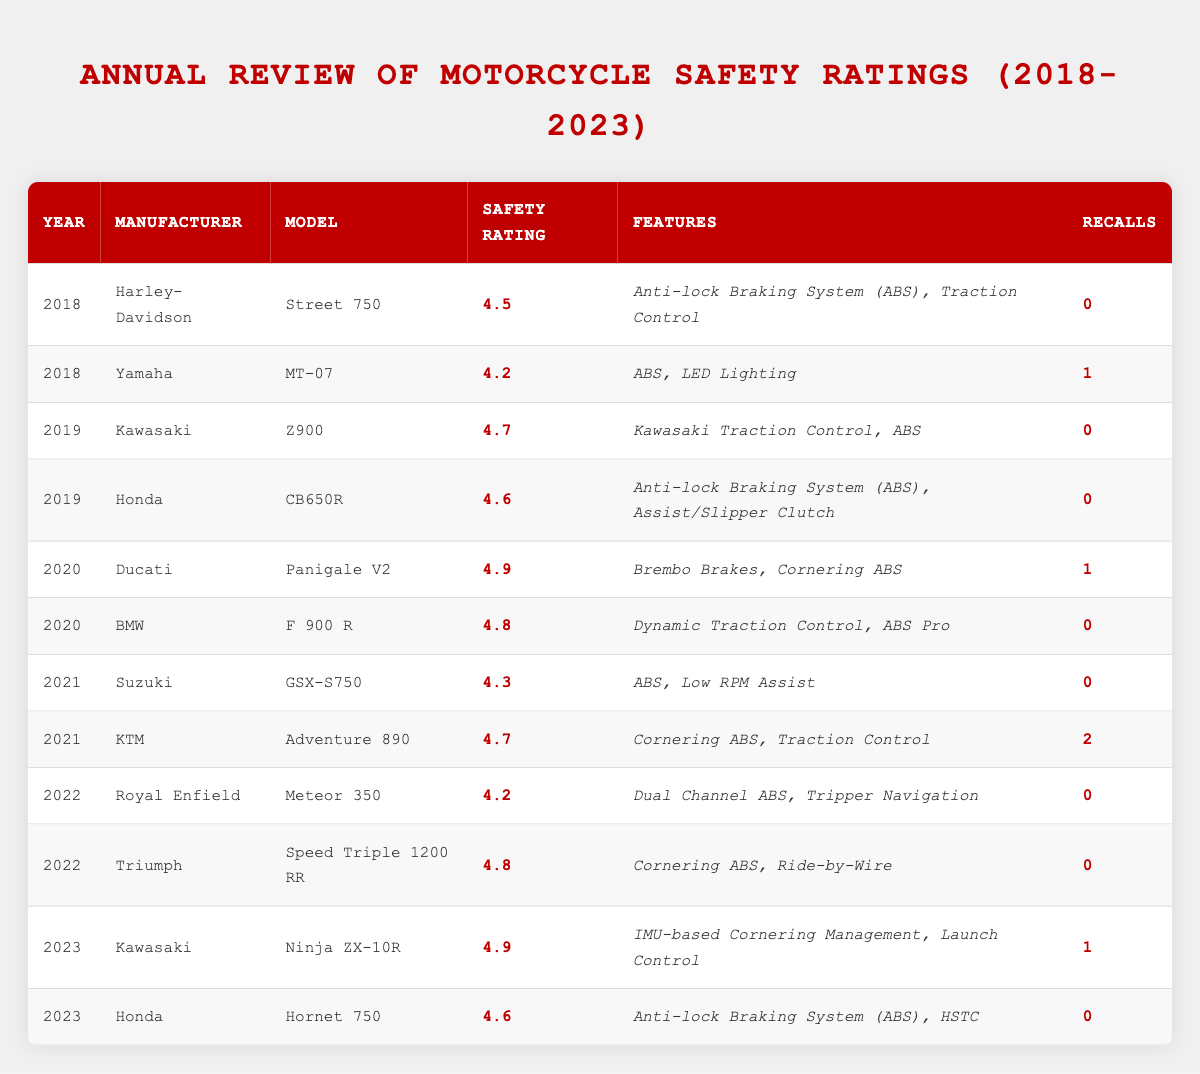What is the highest safety rating achieved in 2020? The highest safety rating in 2020 is found by comparing the ratings of Ducati Panigale V2 (4.9) and BMW F 900 R (4.8). Here, 4.9 is the highest.
Answer: 4.9 Which manufacturer had a model with the least recalls in 2019? In 2019, both Kawasaki Z900 and Honda CB650R had 0 recalls, which is the least.
Answer: Kawasaki and Honda What is the average safety rating from 2018 to 2023? The safety ratings from 2018 to 2023 are: 4.5, 4.2, 4.7, 4.6, 4.9, 4.8, 4.3, 4.7, 4.2, 4.8, 4.9, and 4.6. The total is 53.4. There are 12 models, so the average is 53.4/12 = 4.45.
Answer: 4.45 Which year had the most recalls across all models? Looking at the recalls per model, in 2021, KTM Adventure 890 had 2 recalls while all other years' recalls either had 0 or 1 (2018 - 0, 2019 - 0, 2020 - 1, 2022 - 0, 2023 - 1). Therefore, 2021 has the most recalls.
Answer: 2021 What percentage of models in 2022 had a safety rating of 4.5 or higher? In 2022, there are 2 models: Royal Enfield Meteor 350 (4.2) and Triumph Speed Triple 1200 RR (4.8). Only the Triumph model has a safety rating of 4.5 or higher. Therefore, the percentage is (1/2) * 100 = 50%.
Answer: 50% Did any motorcycle model in 2023 have a safety rating lower than 4.5? In 2023, the models are Kawasaki Ninja ZX-10R (4.9) and Honda Hornet 750 (4.6). Both ratings are above 4.5. Thus, no model had a rating lower than 4.5.
Answer: No What is the difference in safety ratings between the highest-rated model in 2020 and the highest-rated model in 2023? The highest-rated model in 2020 is Ducati Panigale V2 with 4.9, and the highest-rated model in 2023 is Kawasaki Ninja ZX-10R, also with 4.9. The difference is 4.9 - 4.9 = 0.
Answer: 0 How many manufacturers had models rated 4.7 or higher in 2019? In 2019, Kawasaki Z900 (4.7) and Honda CB650R (4.6) met the criteria. Only Kawasaki had a rating of 4.7 or higher. Thus, there is 1 manufacturer.
Answer: 1 Is the safety rating for the Harley-Davidson Street 750 higher than that for the Royal Enfield Meteor 350? Harley-Davidson Street 750 has a safety rating of 4.5, while Royal Enfield Meteor 350 has 4.2. Therefore, 4.5 is higher than 4.2.
Answer: Yes 